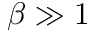<formula> <loc_0><loc_0><loc_500><loc_500>\beta \gg 1</formula> 